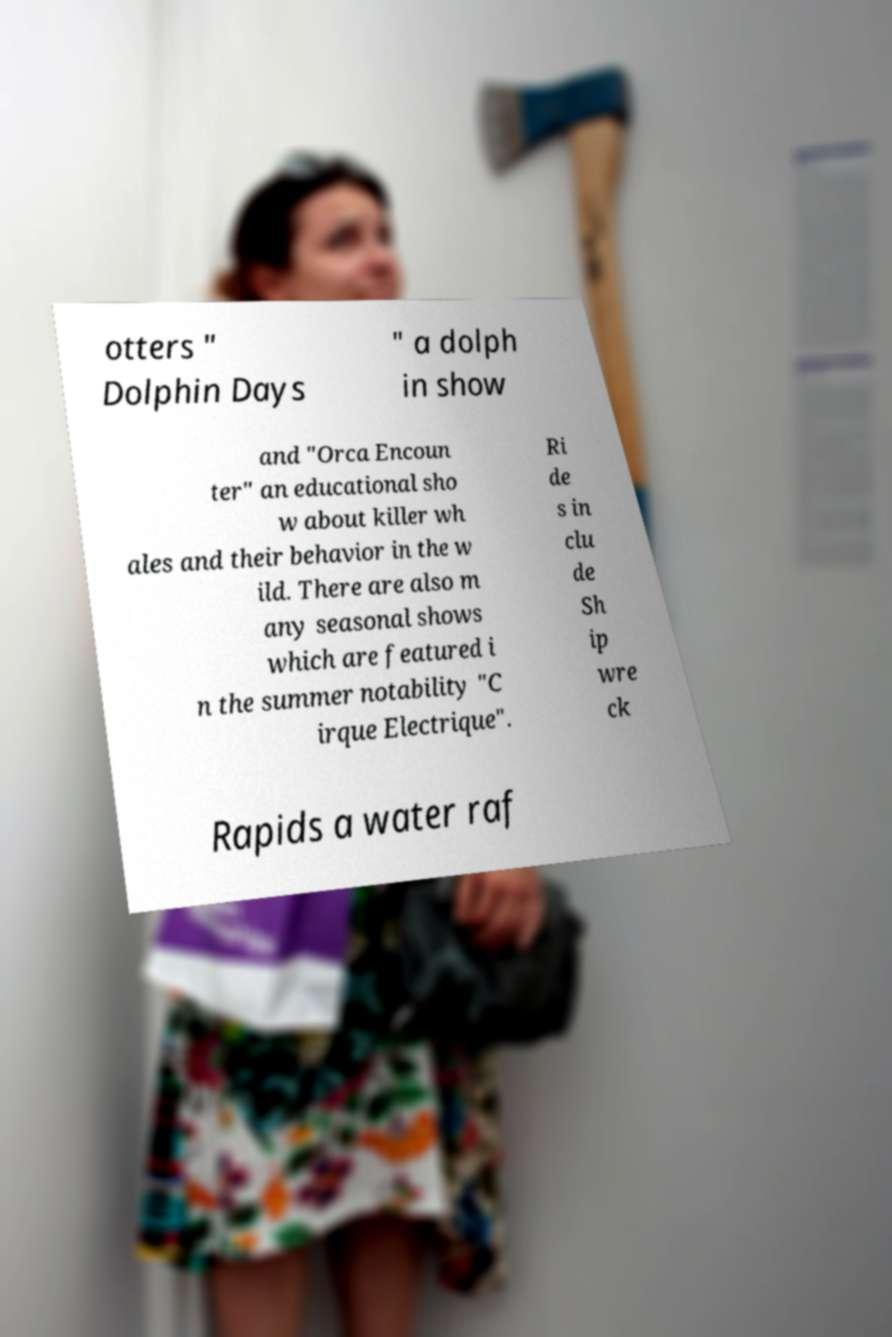Please identify and transcribe the text found in this image. otters " Dolphin Days " a dolph in show and "Orca Encoun ter" an educational sho w about killer wh ales and their behavior in the w ild. There are also m any seasonal shows which are featured i n the summer notability "C irque Electrique". Ri de s in clu de Sh ip wre ck Rapids a water raf 